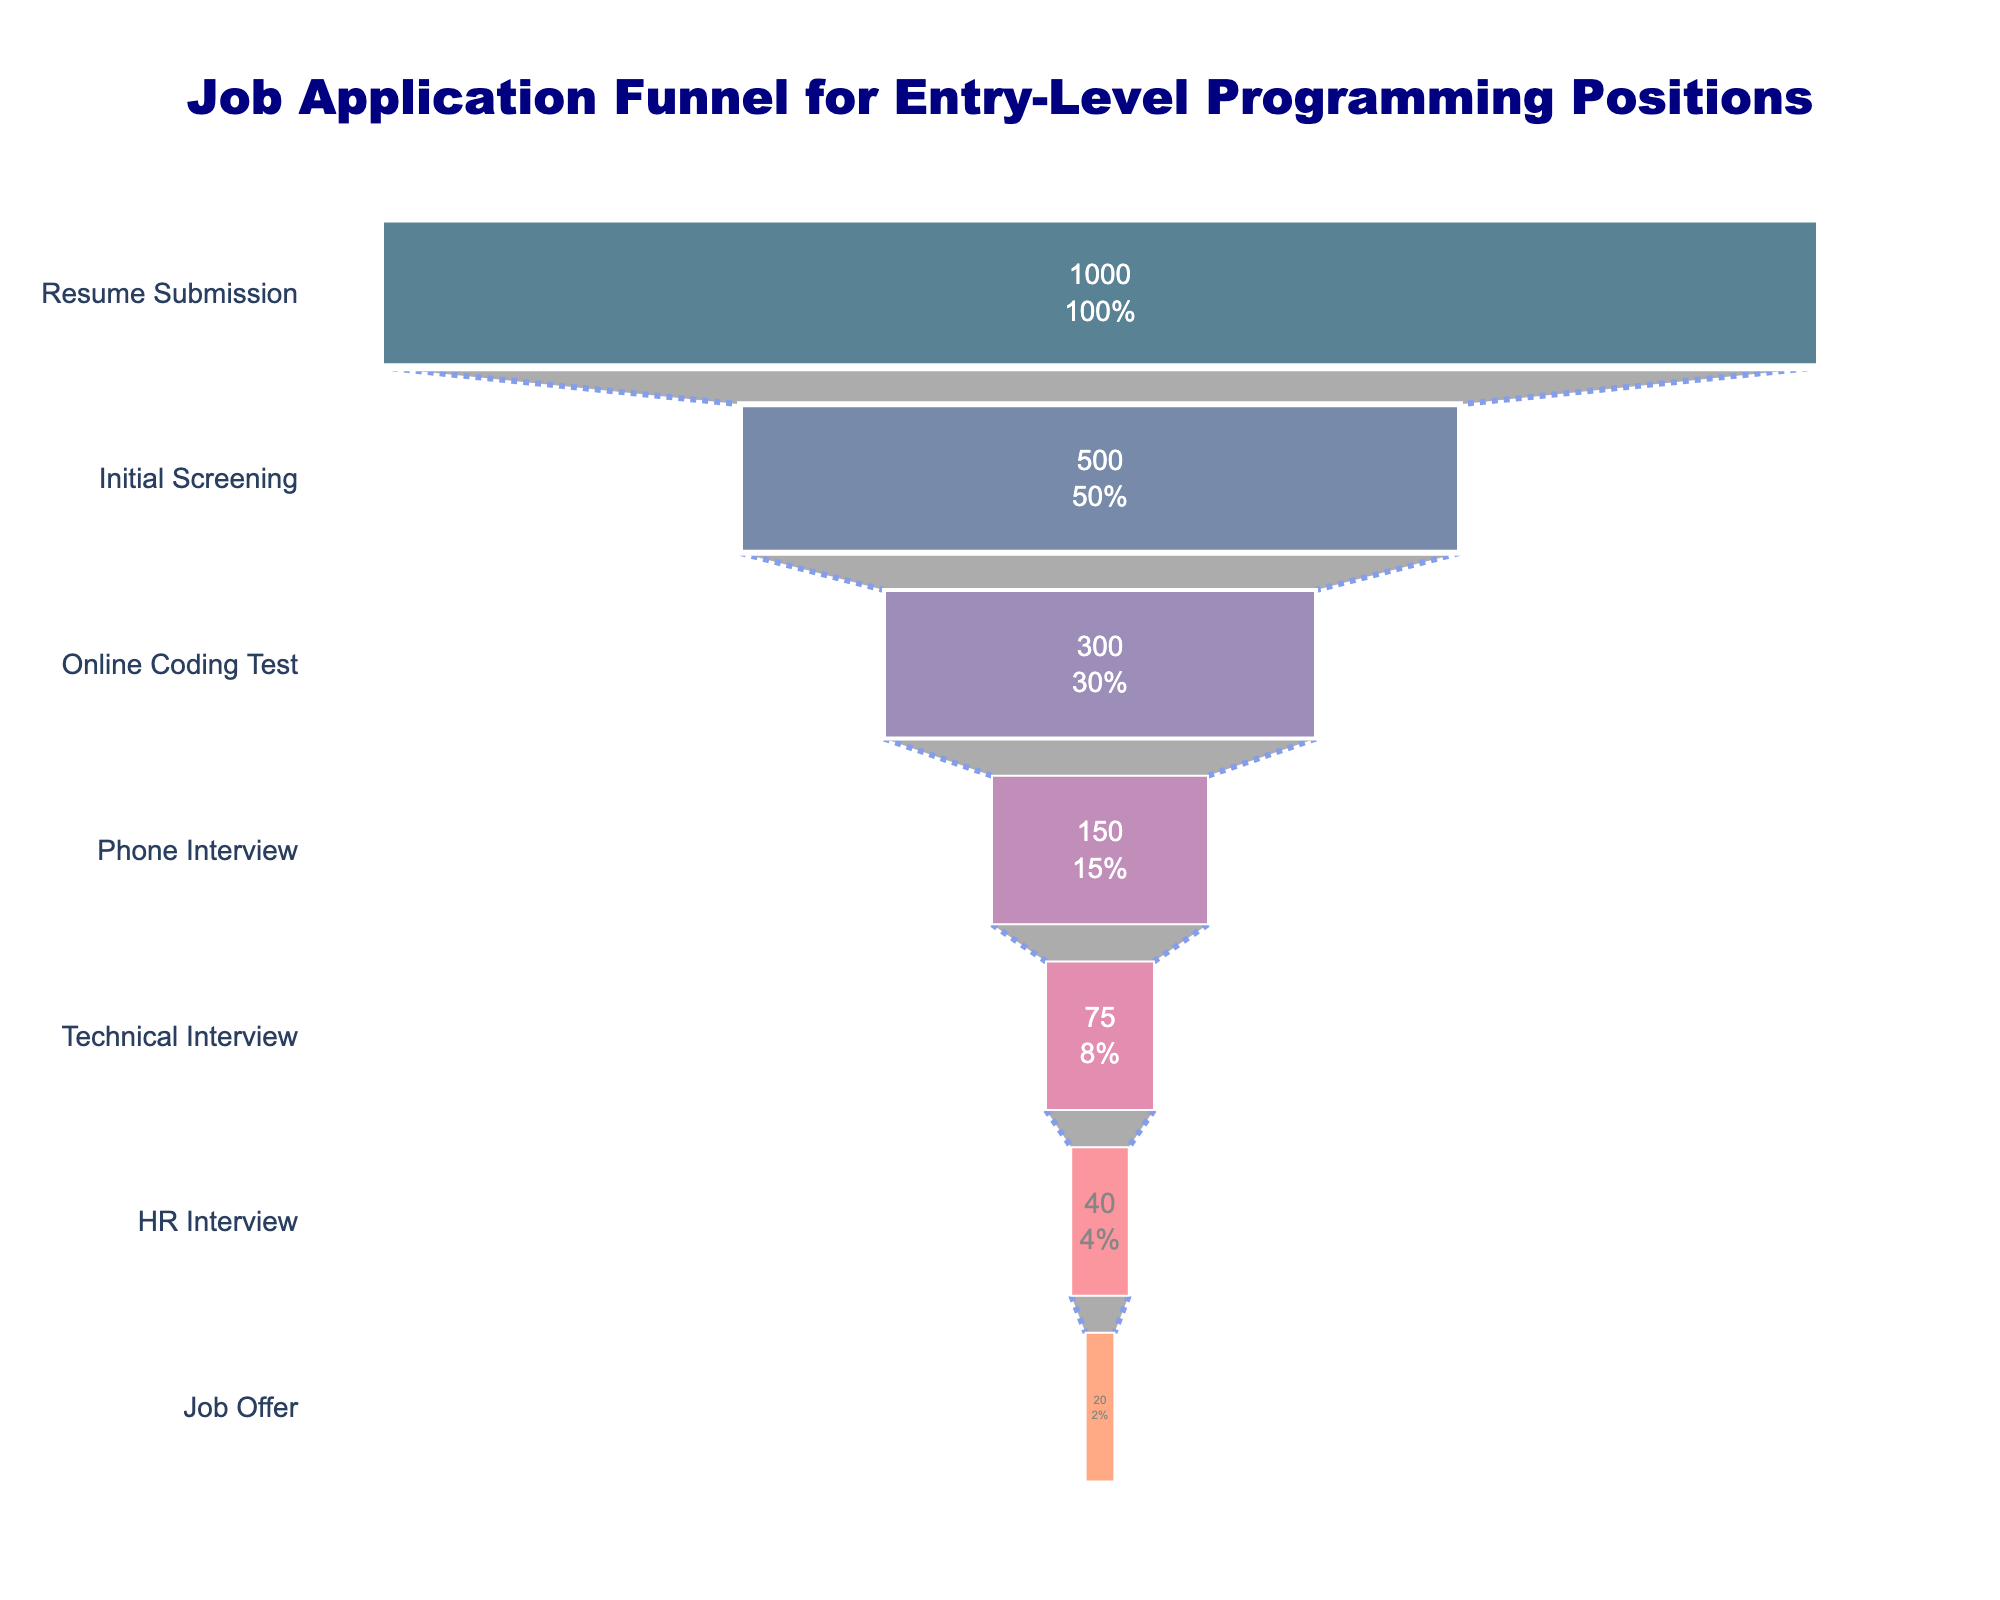How many stages are shown in the funnel chart? There are seven stages visible on the Y-axis, from Resume Submission to Job Offer.
Answer: 7 What is the title of the funnel chart? The title is located at the top center of the chart.
Answer: Job Application Funnel for Entry-Level Programming Positions At which stage do the applicants get reduced by half for the first time? The applicants drop from 1000 at Resume Submission to 500 at Initial Screening, which is the first halving.
Answer: Initial Screening What is the percentage of applicants that undergo a phone interview out of those who submitted resumes? Initially, there are 1000 applicants, and 150 proceed to the phone interview. (150/1000) * 100% = 15%
Answer: 15% What stages see more than a 50% drop in applicants from the previous stage? Resume Submission to Initial Screening (1000 to 500), Initial Screening to Online Coding Test (500 to 300), and Online Coding Test to Phone Interview (300 to 150) all see more than a 50% drop.
Answer: Resume Submission to Initial Screening, Initial Screening to Online Coding Test, Online Coding Test to Phone Interview Which stage shows the smallest reduction in the number of applicants compared to the previous stage? The reduction is smallest between HR Interview (40) and Job Offer (20), with a difference of 20 applicants.
Answer: HR Interview to Job Offer What percentage of applicants reach the final HR interview stage from the online coding test stage? From the online coding test (300 applicants) to the HR Interview (40 applicants), (40/300) * 100% = 13.33%
Answer: 13.33% By what percentage do the applicants reduce from the Technical Interview to the HR Interview? From the Technical Interview (75 applicants) to the HR Interview (40 applicants), the reduction percentage is ((75 - 40) / 75) * 100% = 46.67%
Answer: 46.67% How many more applicants receive a job offer compared to those reaching the technical interview stage? The number of job offers (20) compared to those at the technical interview stage (75) is a difference of 75 - 20 = 55 applicants.
Answer: 55 